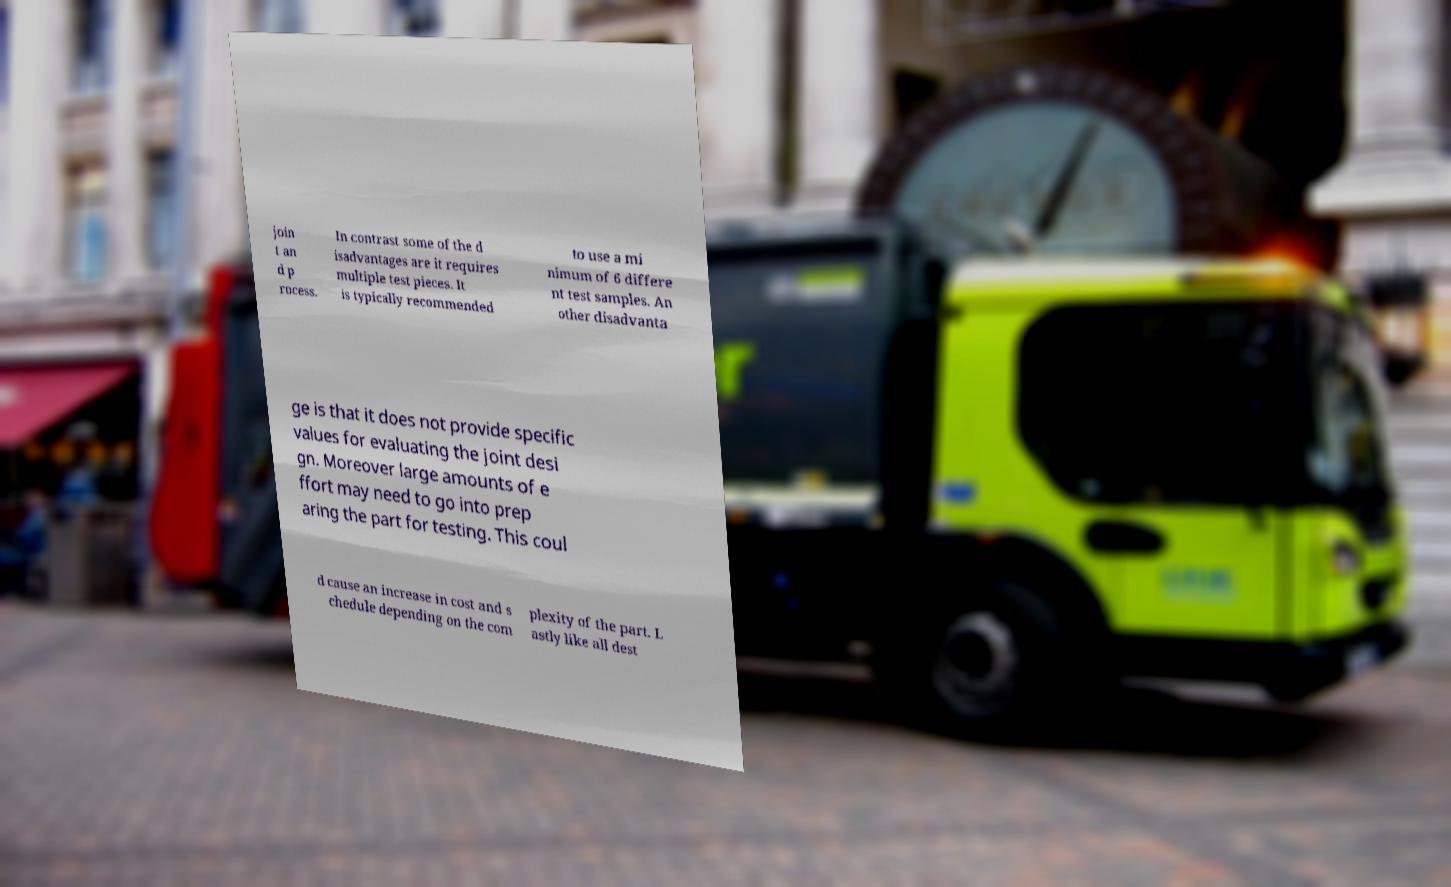Could you assist in decoding the text presented in this image and type it out clearly? join t an d p rocess. In contrast some of the d isadvantages are it requires multiple test pieces. It is typically recommended to use a mi nimum of 6 differe nt test samples. An other disadvanta ge is that it does not provide specific values for evaluating the joint desi gn. Moreover large amounts of e ffort may need to go into prep aring the part for testing. This coul d cause an increase in cost and s chedule depending on the com plexity of the part. L astly like all dest 